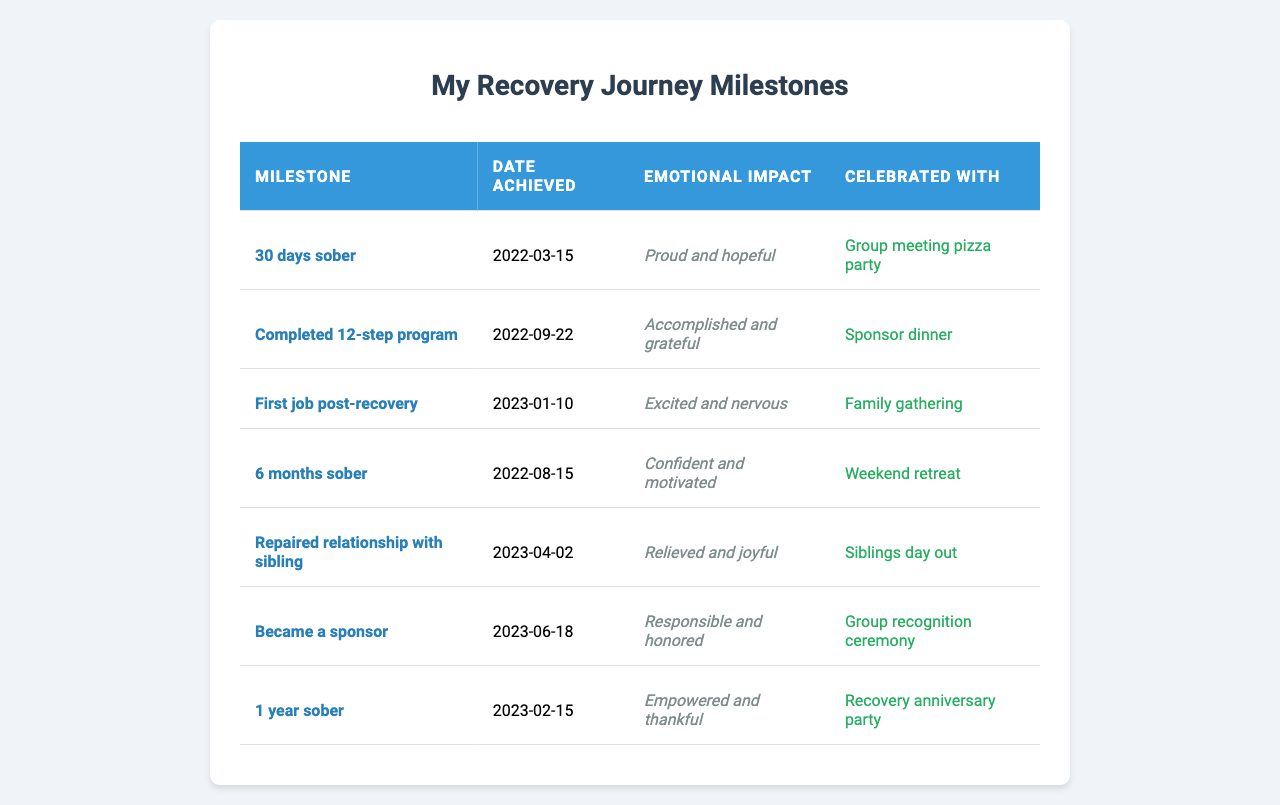What milestone was achieved on March 15, 2022? Referring to the table, the entry on March 15, 2022, shows that the milestone "30 days sober" was achieved on that date.
Answer: 30 days sober How many months of sobriety were celebrated on August 15, 2022? The table indicates that on August 15, 2022, the milestone achieved was "6 months sober."
Answer: 6 months sober What emotional impact is associated with completing the 12-step program? According to the table, the emotional impact related to completing the 12-step program is described as "Accomplished and grateful."
Answer: Accomplished and grateful Which milestone was celebrated with a group recognition ceremony? The table shows that the milestone "Became a sponsor" was celebrated with a group recognition ceremony.
Answer: Became a sponsor Did the person celebrate their 1-year sobriety milestone? Yes, the table confirms that the person celebrated their 1 year sober milestone with a recovery anniversary party.
Answer: Yes How many milestones were achieved before the first job post-recovery? By examining the table, we can see that there were three milestones achieved before the first job: "30 days sober," "6 months sober," and "Completed 12-step program."
Answer: 3 milestones What is the emotional impact of achieving 1 year sober compared to 6 months sober? On comparing the two milestones, "1 year sober" has an emotional impact described as "Empowered and thankful," while "6 months sober" has an impact of "Confident and motivated." Both show positive emotional states, but "1 year sober" seems to express a higher sense of empowerment.
Answer: 1 year sober is more empowering How much time passed between the achievement of "6 months sober" and "1 year sober"? From the dates in the table, "6 months sober" was achieved on August 15, 2022, and "1 year sober" was achieved on February 15, 2023. The time difference is 6 months.
Answer: 6 months What milestone had the most emotional impact according to the table? The milestones are fairly similar in emotional impact; however, "1 year sober" described an emotional impact of "Empowered and thankful," which could suggest it holds significant emotional value. Evaluating the other entries, it appears to be among the most potent.
Answer: 1 year sober Was the relationship with a sibling repaired after 1 year sober? Yes, the table indicates that the "Repaired relationship with sibling" milestone was achieved on April 2, 2023, which is after the "1 year sober" milestone achieved on February 15, 2023.
Answer: Yes 